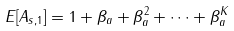Convert formula to latex. <formula><loc_0><loc_0><loc_500><loc_500>E [ A _ { s , 1 } ] = 1 + \beta _ { a } + \beta _ { a } ^ { 2 } + \dots + \beta _ { a } ^ { K }</formula> 